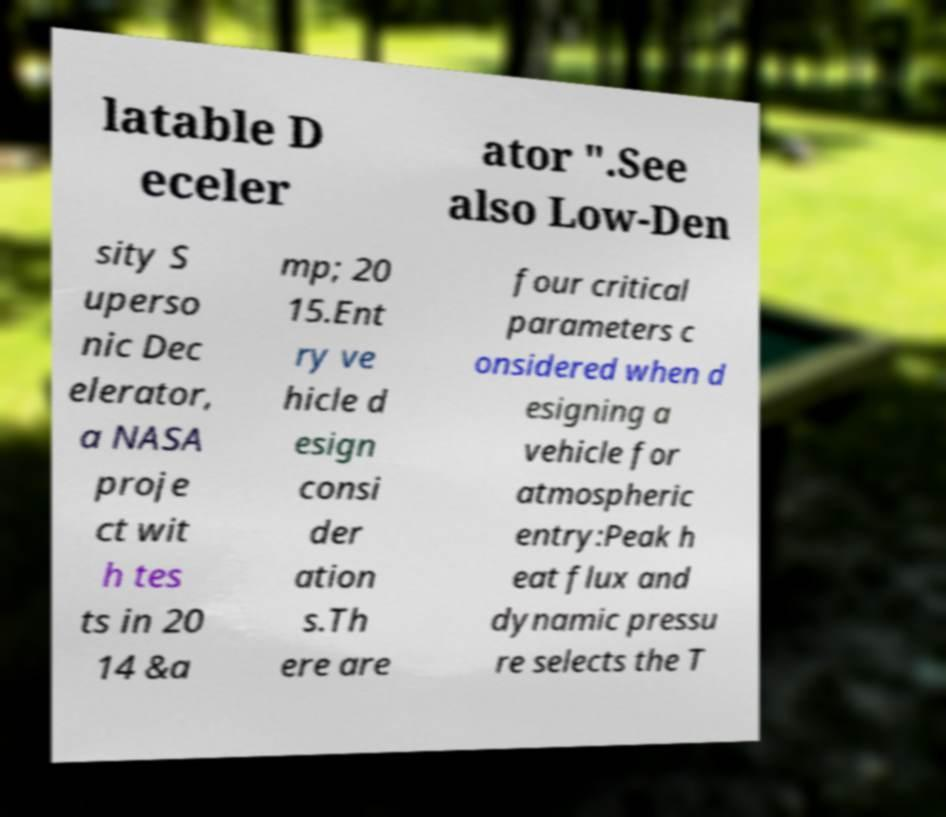I need the written content from this picture converted into text. Can you do that? latable D eceler ator ".See also Low-Den sity S uperso nic Dec elerator, a NASA proje ct wit h tes ts in 20 14 &a mp; 20 15.Ent ry ve hicle d esign consi der ation s.Th ere are four critical parameters c onsidered when d esigning a vehicle for atmospheric entry:Peak h eat flux and dynamic pressu re selects the T 